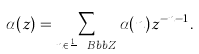Convert formula to latex. <formula><loc_0><loc_0><loc_500><loc_500>\alpha ( z ) = \sum _ { n \in \frac { 1 } { p } { \ B b b Z } } \alpha ( n ) z ^ { - n - 1 } .</formula> 